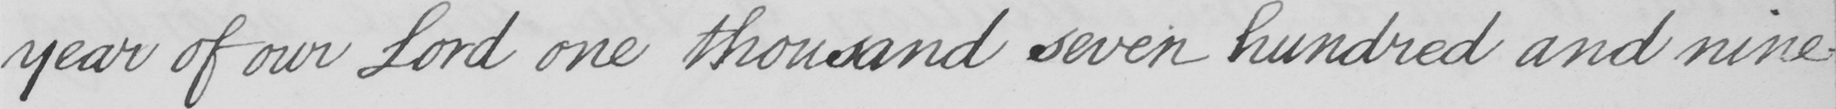Please provide the text content of this handwritten line. year of our Lord one thousand seven hundred and nine- 